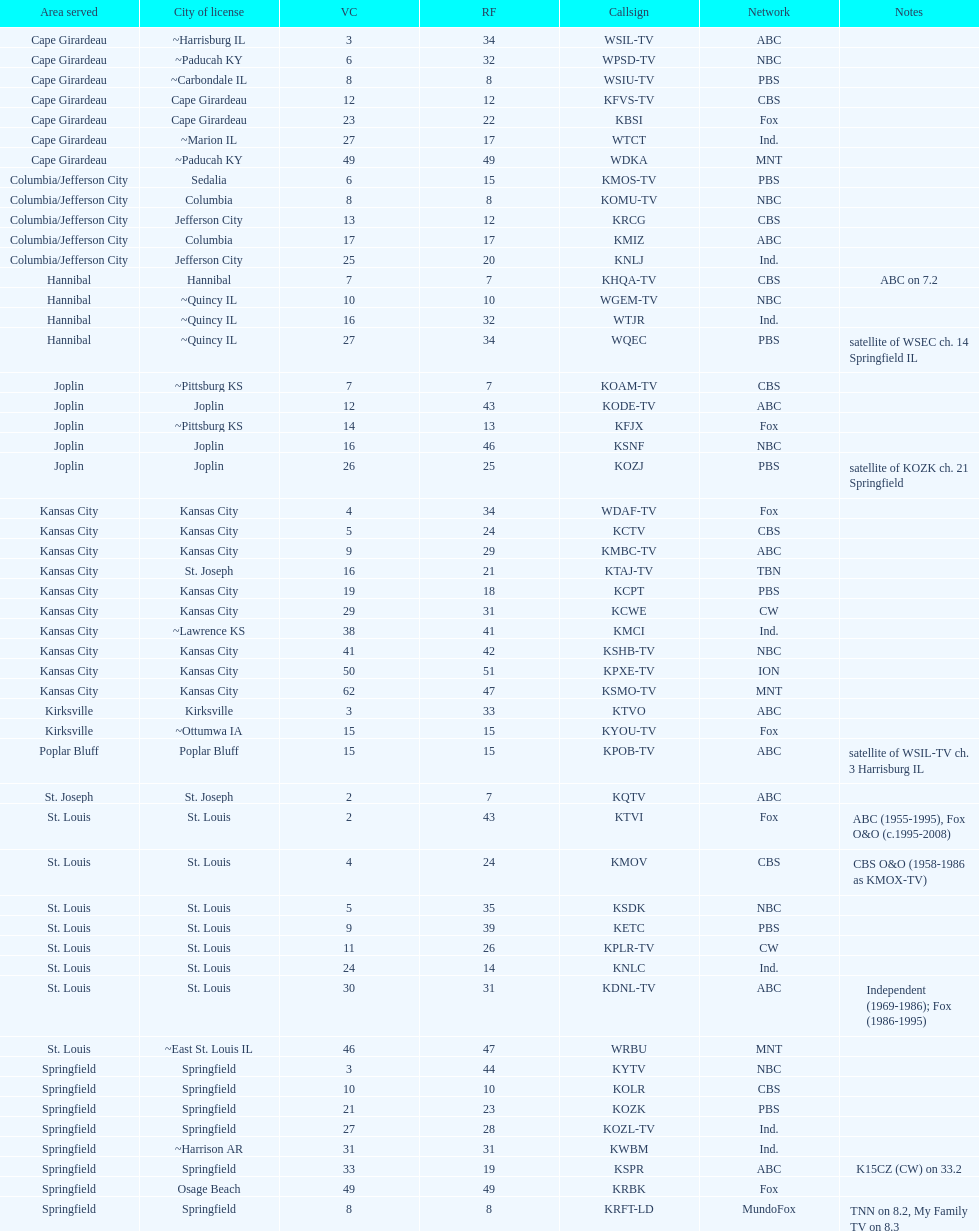How many are on the cbs network? 7. 